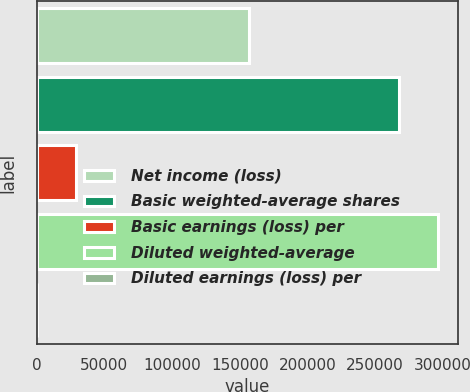Convert chart. <chart><loc_0><loc_0><loc_500><loc_500><bar_chart><fcel>Net income (loss)<fcel>Basic weighted-average shares<fcel>Basic earnings (loss) per<fcel>Diluted weighted-average<fcel>Diluted earnings (loss) per<nl><fcel>156701<fcel>267291<fcel>28982.7<fcel>296273<fcel>0.54<nl></chart> 